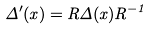Convert formula to latex. <formula><loc_0><loc_0><loc_500><loc_500>\Delta ^ { \prime } ( x ) = R \Delta ( x ) R ^ { - 1 }</formula> 